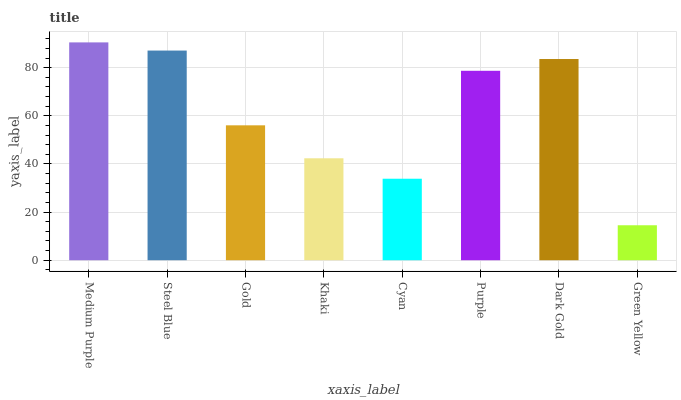Is Steel Blue the minimum?
Answer yes or no. No. Is Steel Blue the maximum?
Answer yes or no. No. Is Medium Purple greater than Steel Blue?
Answer yes or no. Yes. Is Steel Blue less than Medium Purple?
Answer yes or no. Yes. Is Steel Blue greater than Medium Purple?
Answer yes or no. No. Is Medium Purple less than Steel Blue?
Answer yes or no. No. Is Purple the high median?
Answer yes or no. Yes. Is Gold the low median?
Answer yes or no. Yes. Is Medium Purple the high median?
Answer yes or no. No. Is Khaki the low median?
Answer yes or no. No. 